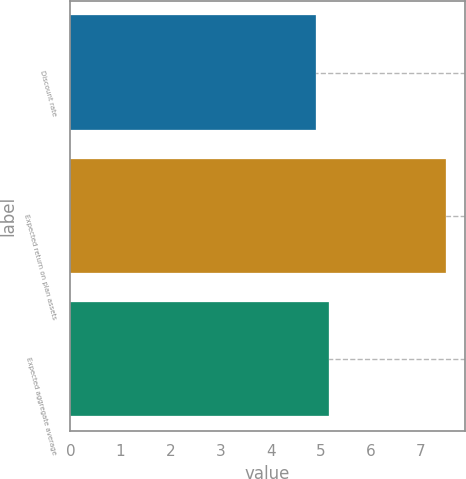Convert chart. <chart><loc_0><loc_0><loc_500><loc_500><bar_chart><fcel>Discount rate<fcel>Expected return on plan assets<fcel>Expected aggregate average<nl><fcel>4.9<fcel>7.5<fcel>5.16<nl></chart> 